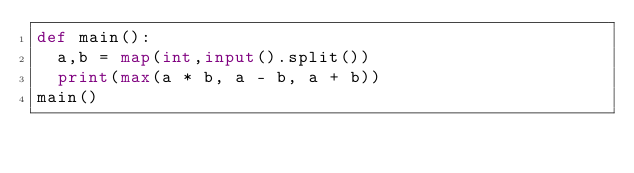<code> <loc_0><loc_0><loc_500><loc_500><_Python_>def main():
  a,b = map(int,input().split())
  print(max(a * b, a - b, a + b))
main()</code> 